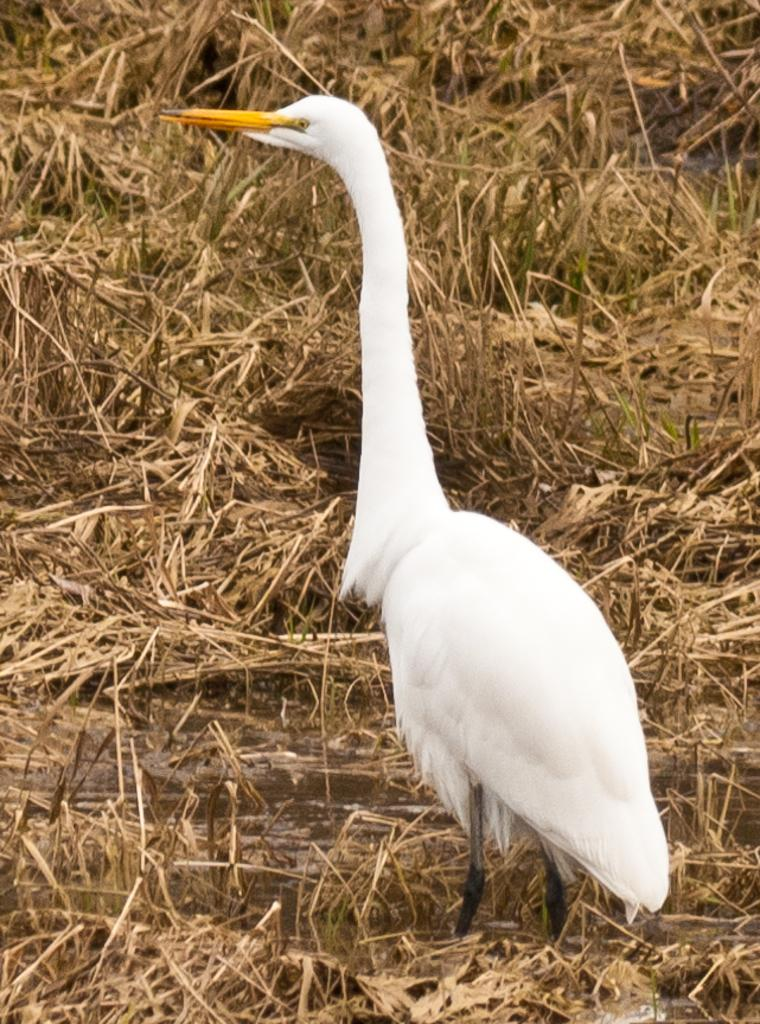What is the main subject of the image? There is a crane in the image. What is the crane doing in the image? The crane is standing. What can be seen in the background of the image? There is lawn straw visible in the background of the image. What year is depicted in the image? The image does not depict a specific year; it is a photograph of a crane standing on a lawn with straw in the background. Can you see any geese in the image? There are no geese present in the image. 